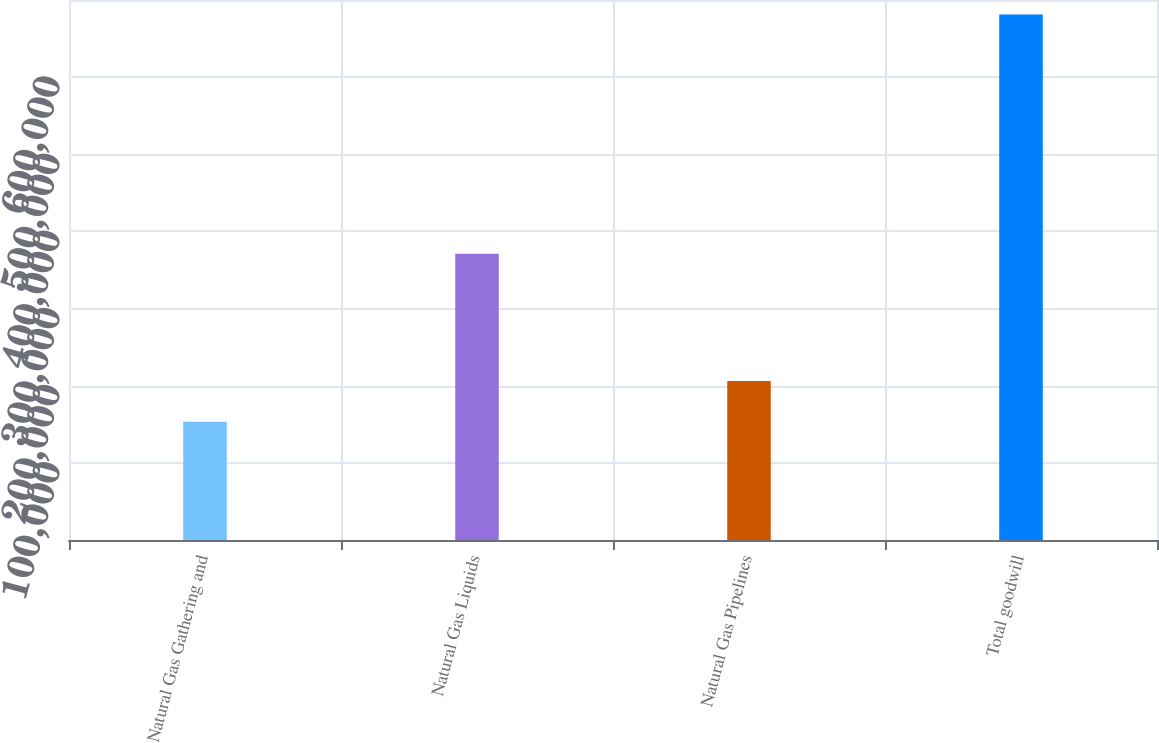<chart> <loc_0><loc_0><loc_500><loc_500><bar_chart><fcel>Natural Gas Gathering and<fcel>Natural Gas Liquids<fcel>Natural Gas Pipelines<fcel>Total goodwill<nl><fcel>153404<fcel>371217<fcel>206174<fcel>681100<nl></chart> 